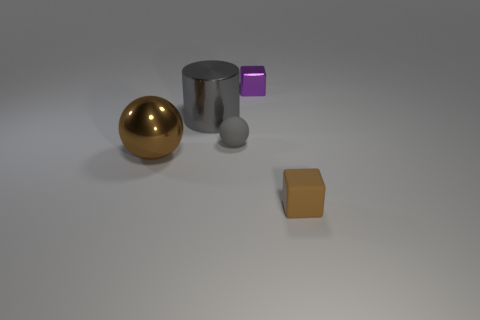How would you describe the lighting and shadows in the scene? The lighting in the scene appears to be soft and diffused, creating gentle shadows that suggest an overcast or indirect light source. The directionality of the shadows indicates that the light may be coming from the upper left side of the composition. Each object casts a consistent shadow, grounding them in the space and giving a sense of their dimensions and the distance between them. 